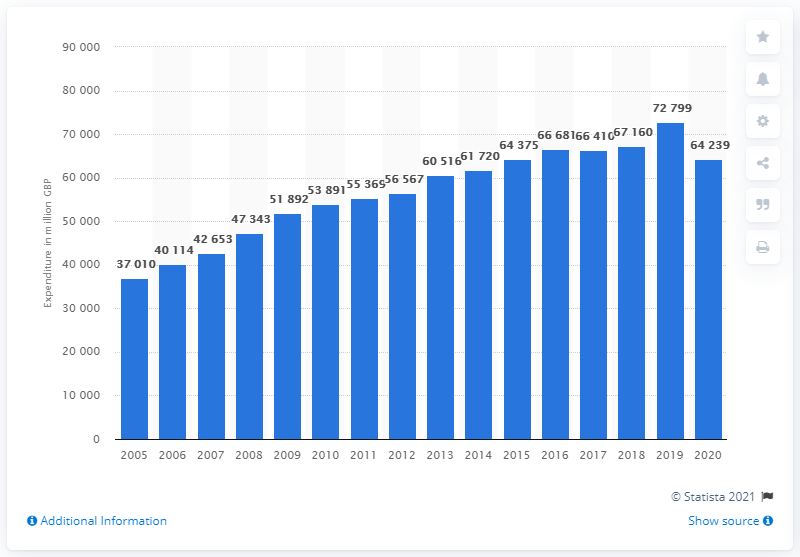Draw attention to some important aspects in this diagram. In 2020, UK households purchased approximately 64,239 units of clothing and footwear. 